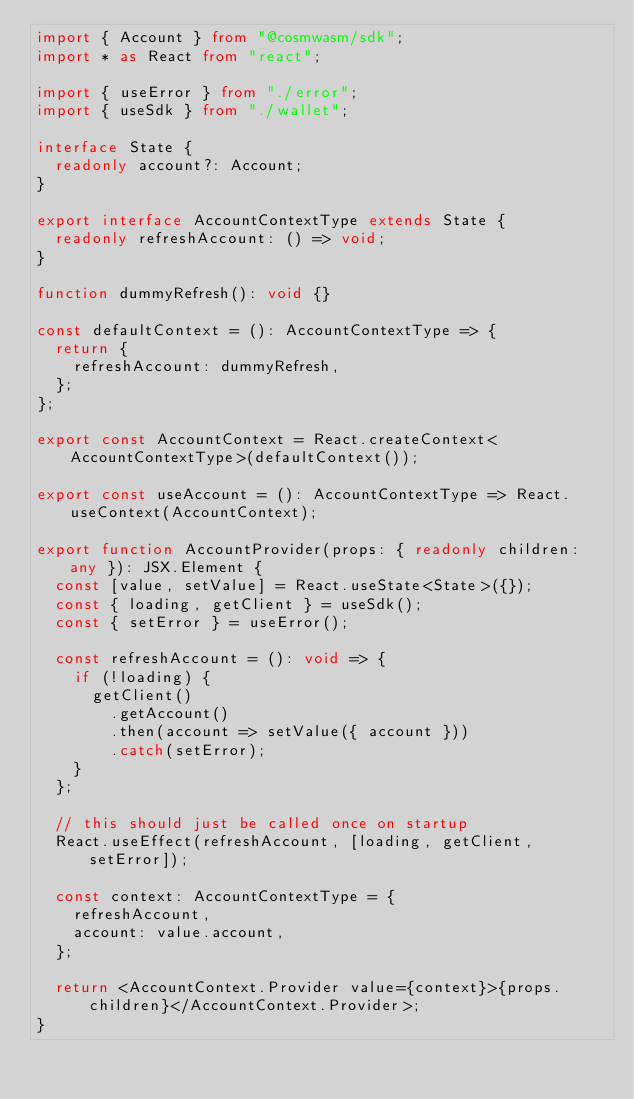Convert code to text. <code><loc_0><loc_0><loc_500><loc_500><_TypeScript_>import { Account } from "@cosmwasm/sdk";
import * as React from "react";

import { useError } from "./error";
import { useSdk } from "./wallet";

interface State {
  readonly account?: Account;
}

export interface AccountContextType extends State {
  readonly refreshAccount: () => void;
}

function dummyRefresh(): void {}

const defaultContext = (): AccountContextType => {
  return {
    refreshAccount: dummyRefresh,
  };
};

export const AccountContext = React.createContext<AccountContextType>(defaultContext());

export const useAccount = (): AccountContextType => React.useContext(AccountContext);

export function AccountProvider(props: { readonly children: any }): JSX.Element {
  const [value, setValue] = React.useState<State>({});
  const { loading, getClient } = useSdk();
  const { setError } = useError();

  const refreshAccount = (): void => {
    if (!loading) {
      getClient()
        .getAccount()
        .then(account => setValue({ account }))
        .catch(setError);
    }
  };

  // this should just be called once on startup
  React.useEffect(refreshAccount, [loading, getClient, setError]);

  const context: AccountContextType = {
    refreshAccount,
    account: value.account,
  };

  return <AccountContext.Provider value={context}>{props.children}</AccountContext.Provider>;
}
</code> 